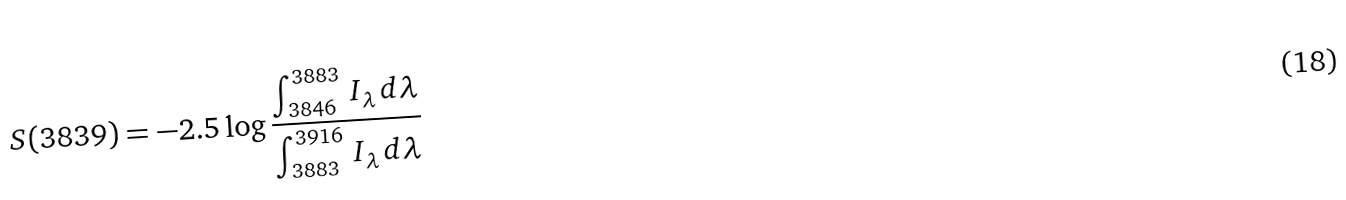Convert formula to latex. <formula><loc_0><loc_0><loc_500><loc_500>S ( 3 8 3 9 ) = - 2 . 5 \log \frac { \int _ { 3 8 4 6 } ^ { 3 8 8 3 } \, I _ { \lambda } \, d \lambda } { \int _ { 3 8 8 3 } ^ { 3 9 1 6 } \, I _ { \lambda } \, d \lambda }</formula> 